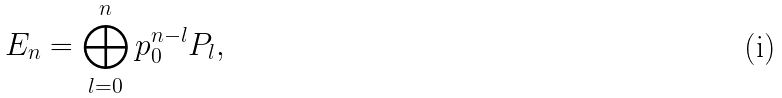<formula> <loc_0><loc_0><loc_500><loc_500>E _ { n } = \bigoplus _ { l = 0 } ^ { n } p _ { 0 } ^ { n - l } P _ { l } ,</formula> 